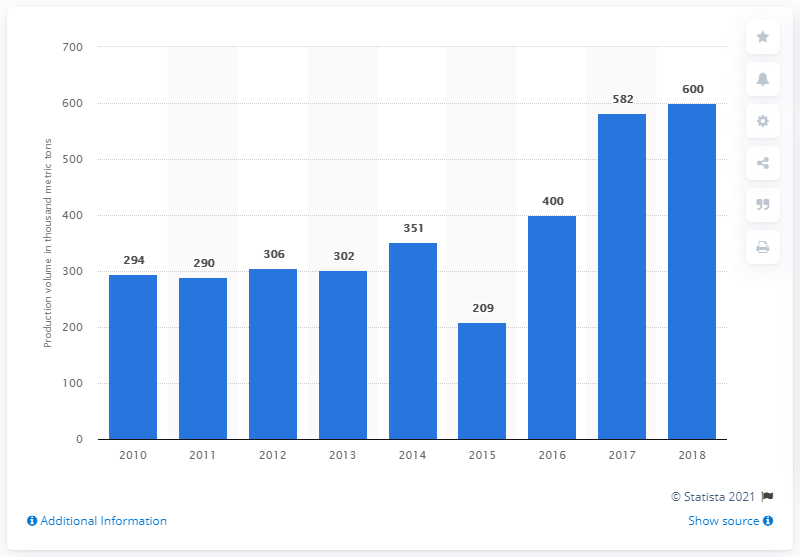List a handful of essential elements in this visual. The year that saw a drastic decrease was 2015. The sum of two highest values is 1182. 